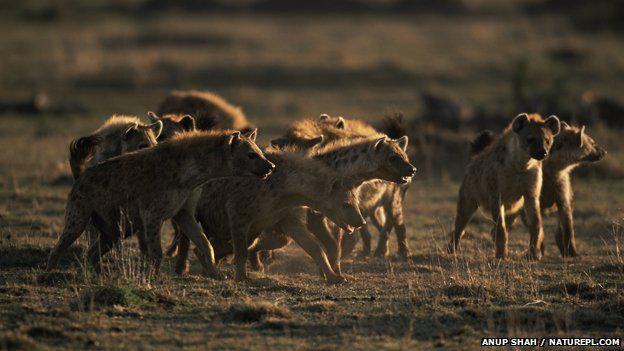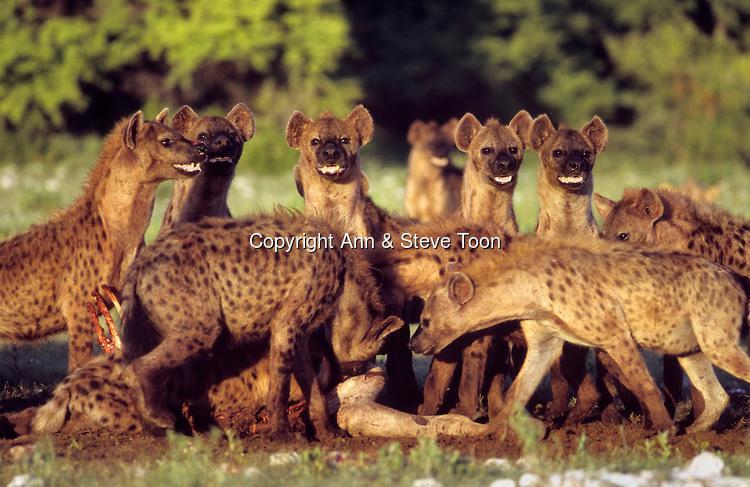The first image is the image on the left, the second image is the image on the right. Considering the images on both sides, is "An image shows an animal with fangs bared surrounded by hyenas." valid? Answer yes or no. No. 